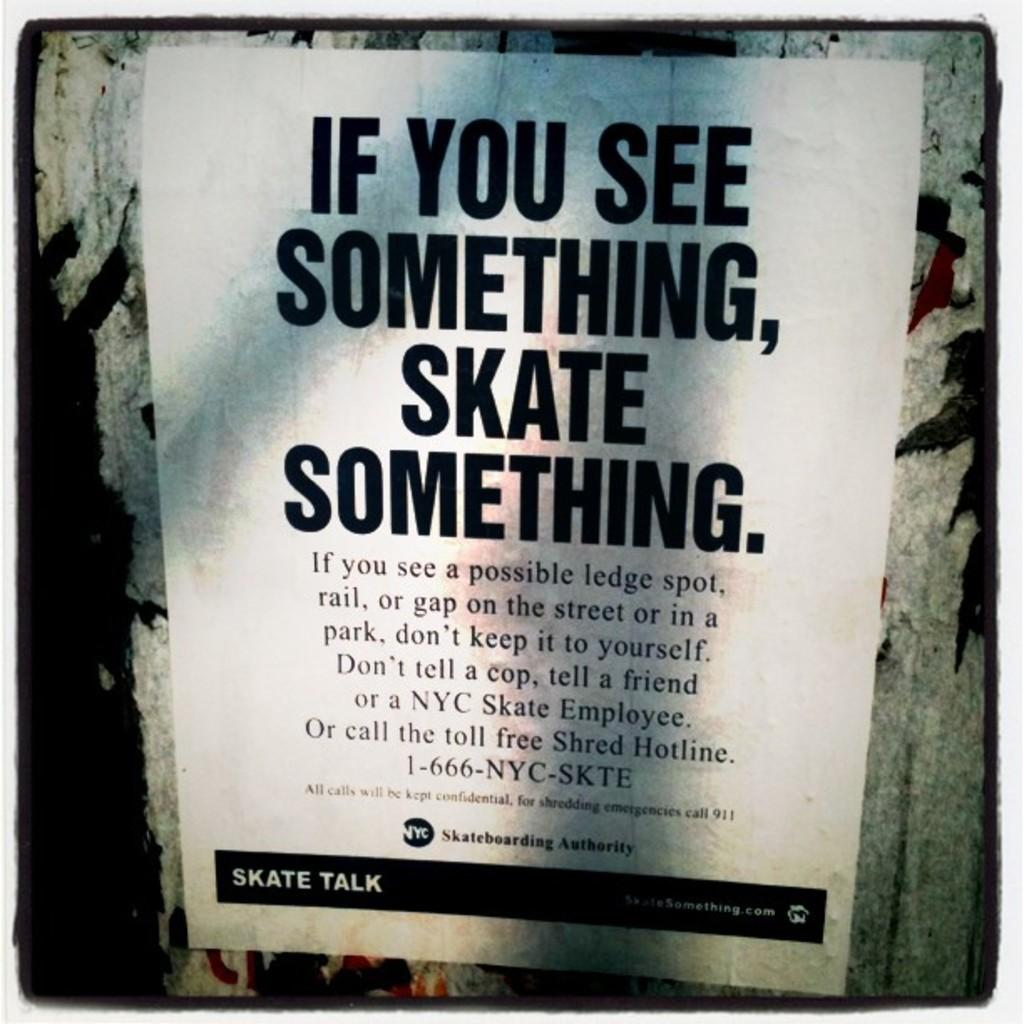<image>
Summarize the visual content of the image. The poster shown is for skater and it encourages skaters to called a free shred hotline. 